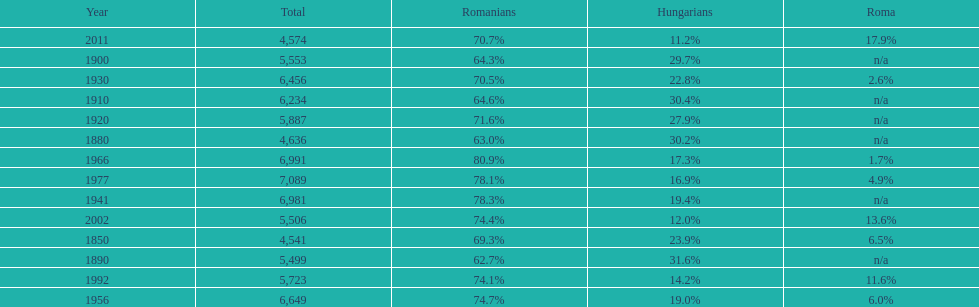Which year had the top percentage in romanian population? 1966. 